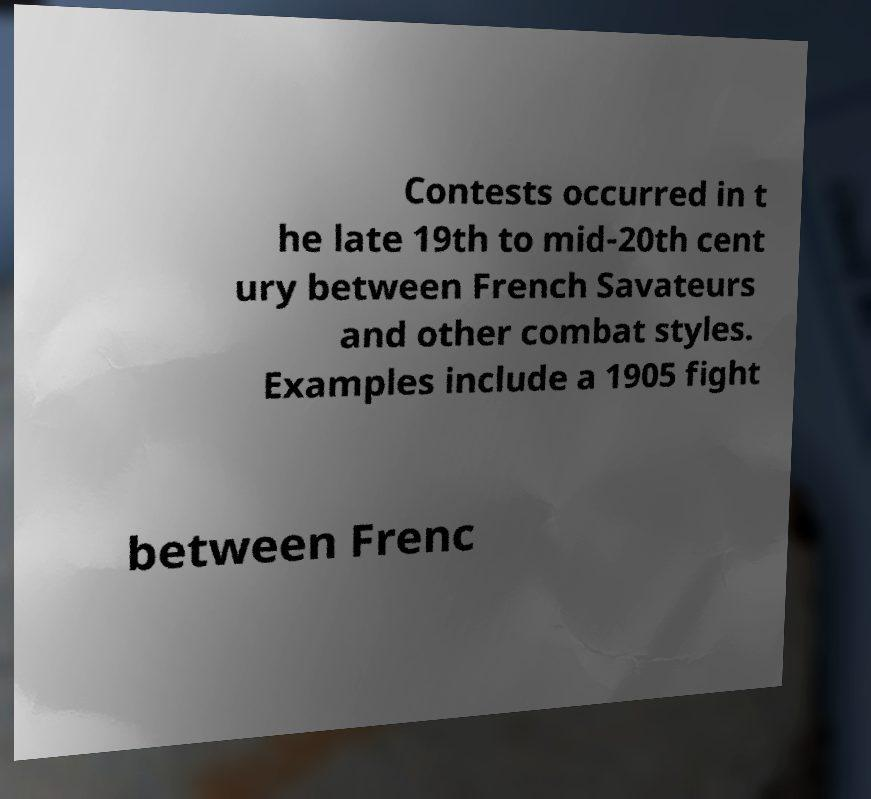Could you extract and type out the text from this image? Contests occurred in t he late 19th to mid-20th cent ury between French Savateurs and other combat styles. Examples include a 1905 fight between Frenc 